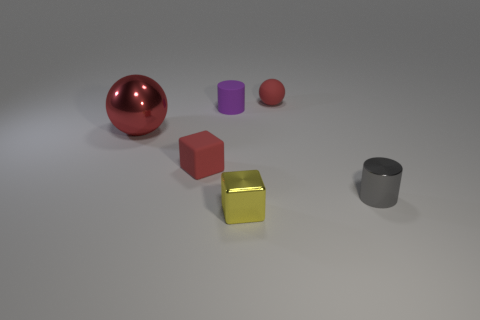Add 4 big red balls. How many objects exist? 10 Subtract all balls. How many objects are left? 4 Add 1 tiny yellow metallic things. How many tiny yellow metallic things exist? 2 Subtract 0 green cylinders. How many objects are left? 6 Subtract all metal balls. Subtract all red spheres. How many objects are left? 3 Add 4 small red matte cubes. How many small red matte cubes are left? 5 